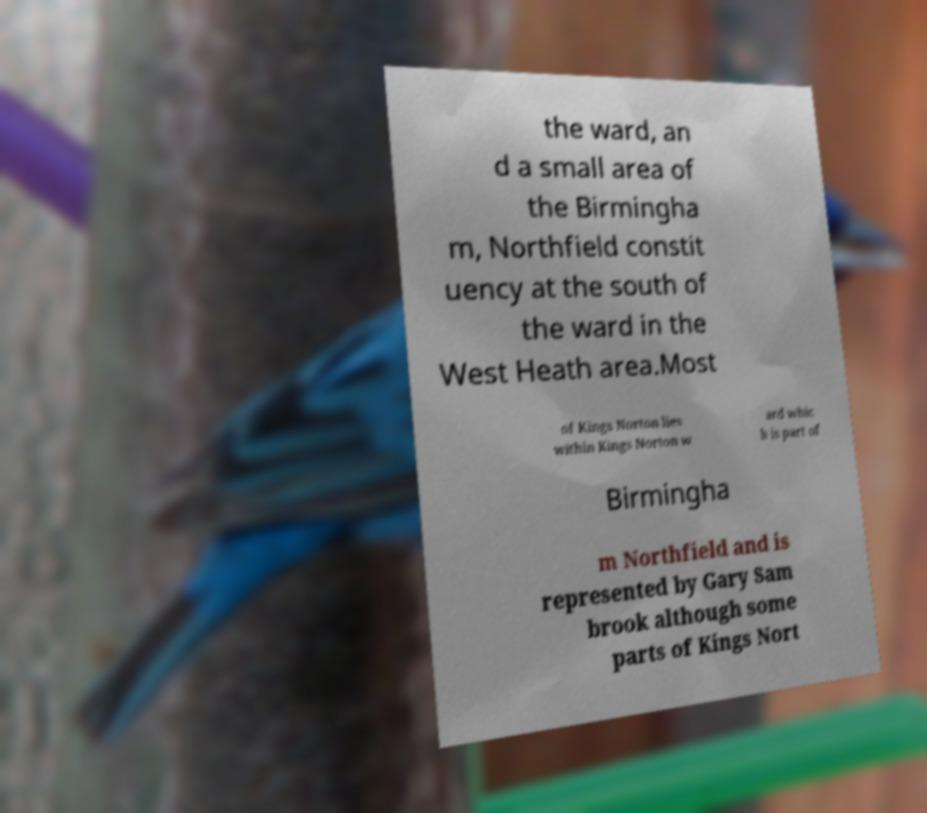What messages or text are displayed in this image? I need them in a readable, typed format. the ward, an d a small area of the Birmingha m, Northfield constit uency at the south of the ward in the West Heath area.Most of Kings Norton lies within Kings Norton w ard whic h is part of Birmingha m Northfield and is represented by Gary Sam brook although some parts of Kings Nort 